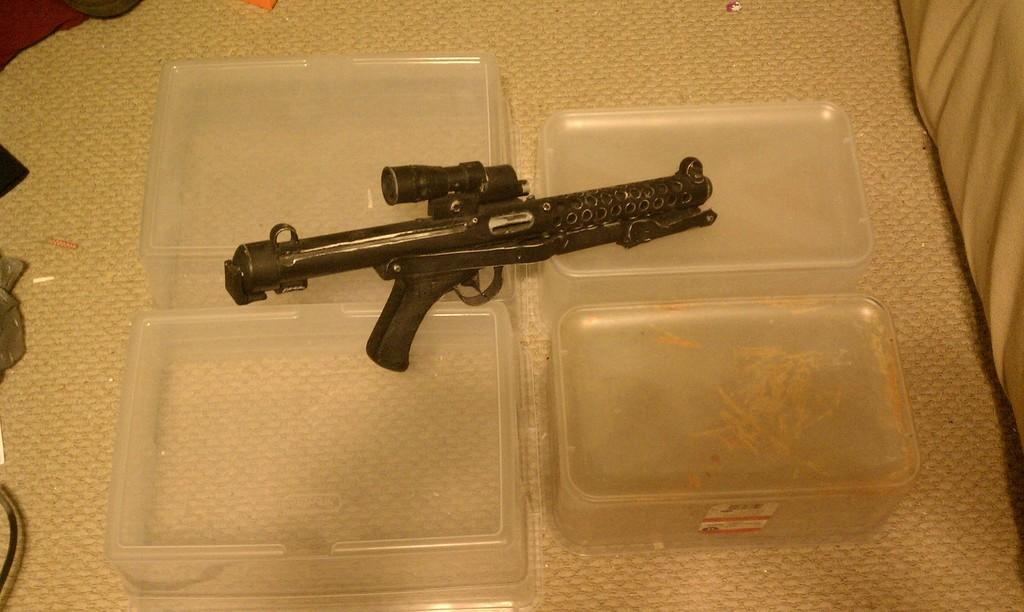What type of furniture is present in the image? There is a table in the image. What objects are placed on the table? There are boxes on the table. What can be seen on top of the boxes? There is a gun on the boxes. Can you see any steam coming from the gun in the image? There is no steam visible in the image, as it features a table, boxes, and a gun. What type of clothing is present on the table in the image? There is no clothing present on the table in the image. 